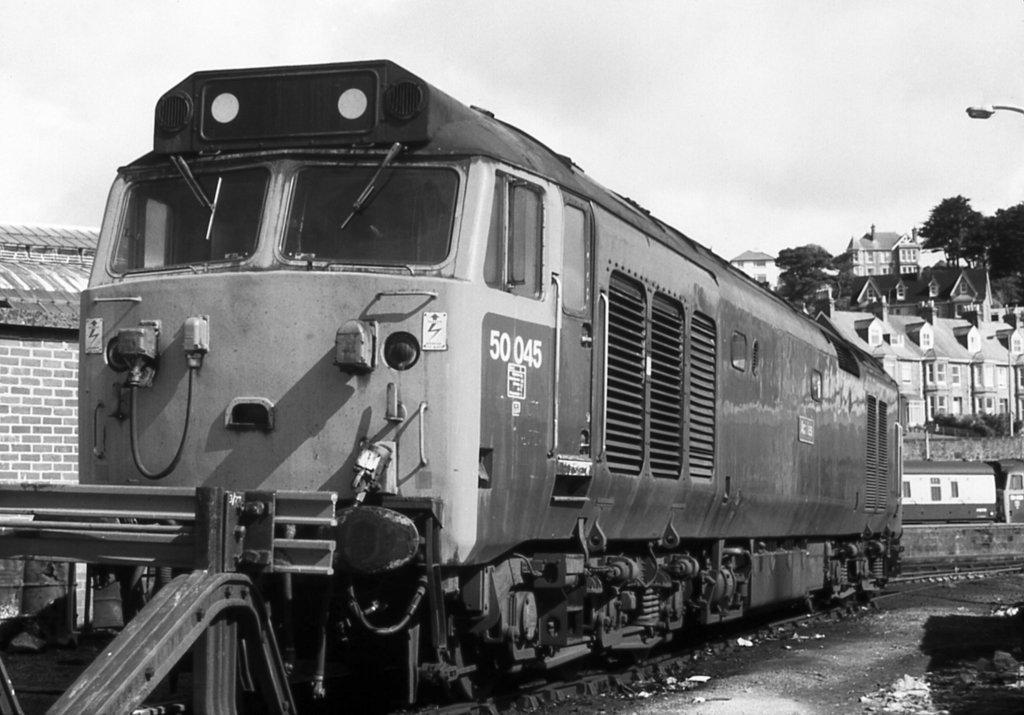Could you give a brief overview of what you see in this image? This is a black and white picture. There is a train on the track. Here we can see wall, trees, light, and buildings. In the background there is sky. 